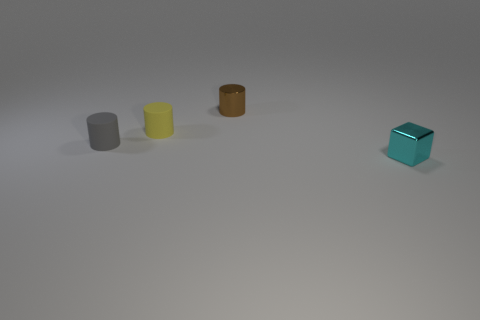Add 2 tiny blue cylinders. How many objects exist? 6 Subtract all cylinders. How many objects are left? 1 Add 2 large green shiny objects. How many large green shiny objects exist? 2 Subtract 0 purple cubes. How many objects are left? 4 Subtract all tiny brown cylinders. Subtract all cylinders. How many objects are left? 0 Add 2 small gray cylinders. How many small gray cylinders are left? 3 